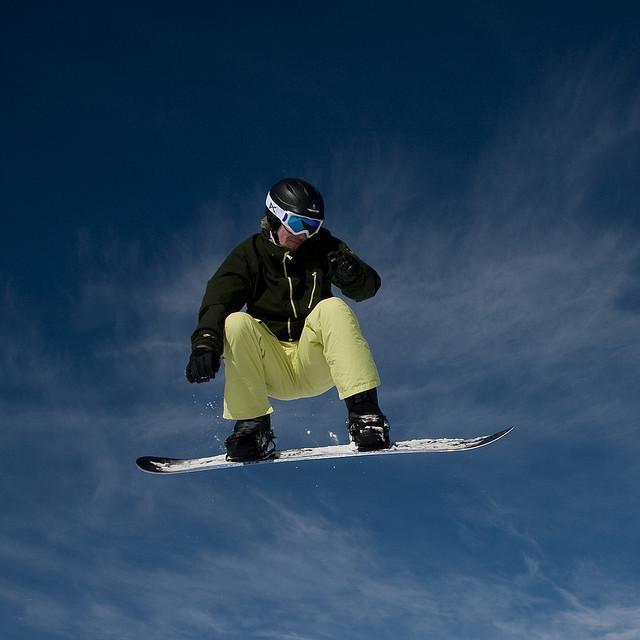How many snowboards are there?
Give a very brief answer. 1. How many bikes are there?
Give a very brief answer. 0. 